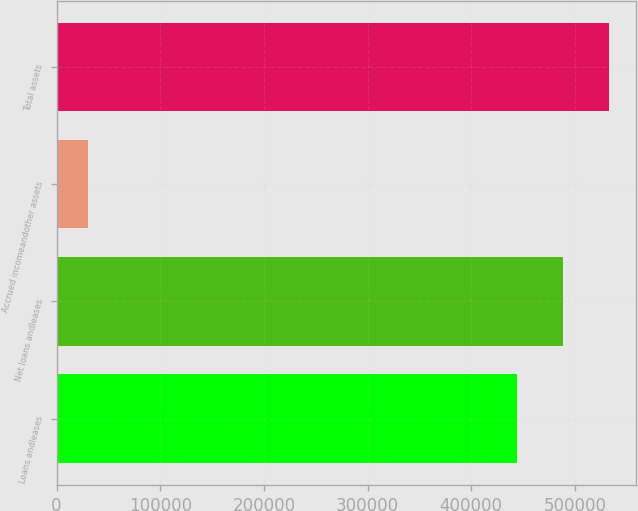Convert chart to OTSL. <chart><loc_0><loc_0><loc_500><loc_500><bar_chart><fcel>Loans andleases<fcel>Net loans andleases<fcel>Accrued incomeandother assets<fcel>Total assets<nl><fcel>443854<fcel>488239<fcel>29857<fcel>532625<nl></chart> 